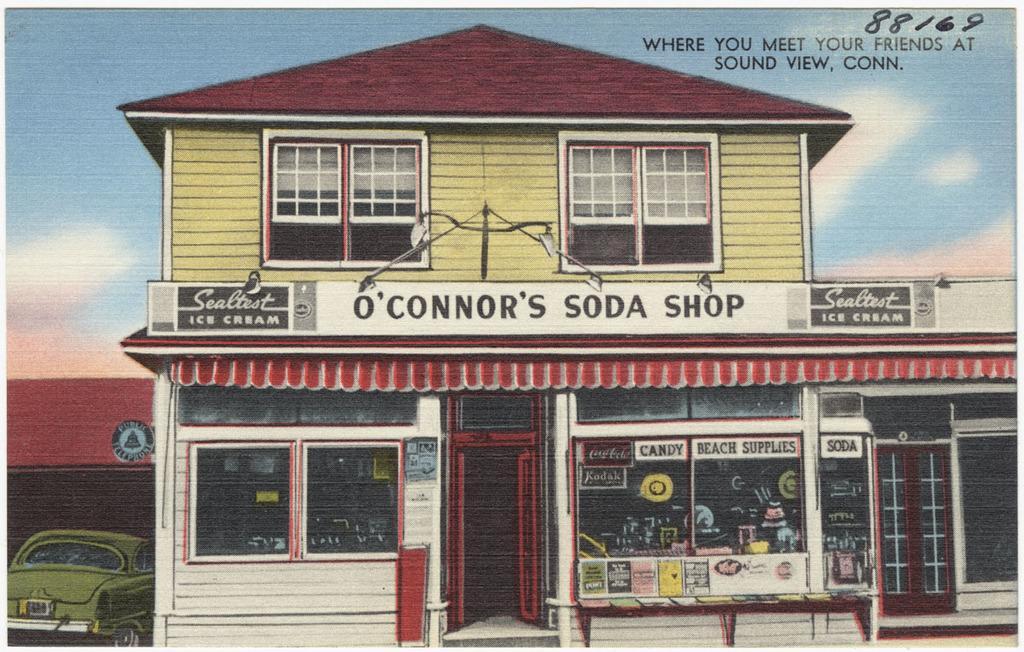Describe this image in one or two sentences. In this image I can see a building which is white, red and yellow in color. I can see a car which is green in color. In the background I can see the sky. 